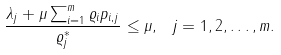Convert formula to latex. <formula><loc_0><loc_0><loc_500><loc_500>\frac { \lambda _ { j } + \mu \sum _ { i = 1 } ^ { m } \varrho _ { i } p _ { i , j } } { \varrho _ { j } ^ { * } } \leq \mu , \ j = 1 , 2 , \dots , m .</formula> 